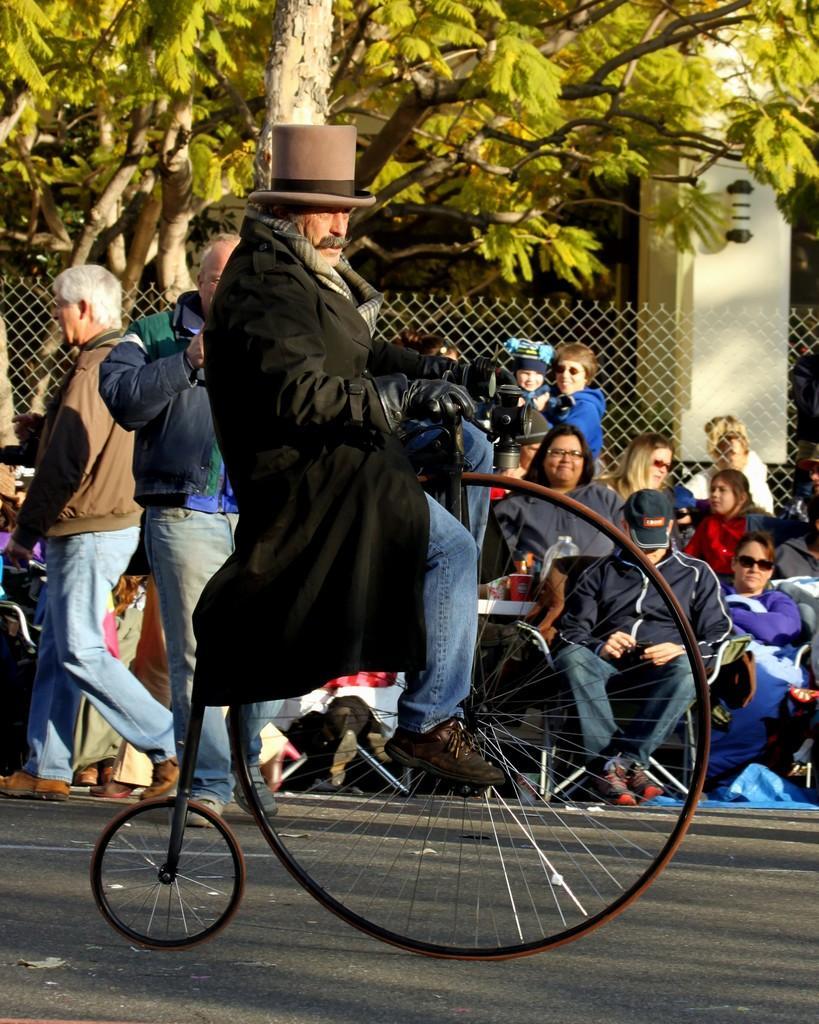In one or two sentences, can you explain what this image depicts? Here is a man sitting and riding the retro bicycle,which has a big front wheel and a small back wheel. At background there are group of people sitting and few are standing. This is a fencing wire and this is a tree. This looks like a pillar with a lamp attached to the pillar. 